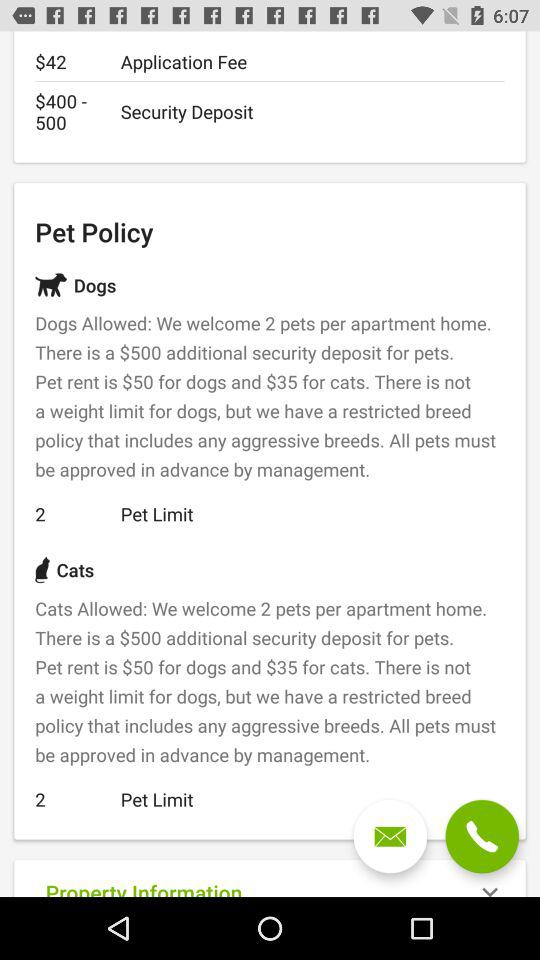What is the application fee? The application fee is $42. 